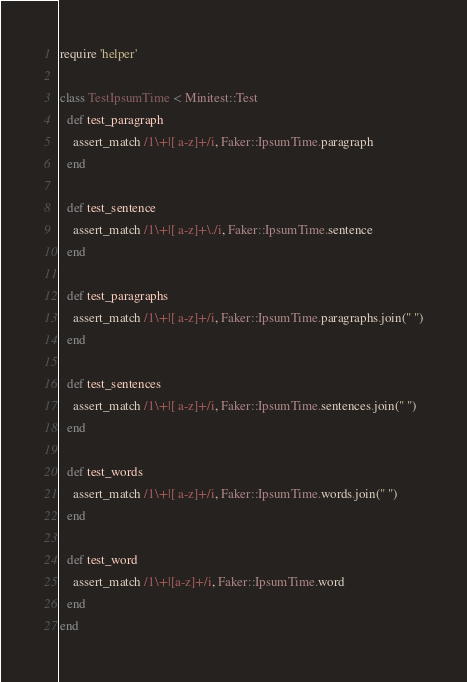Convert code to text. <code><loc_0><loc_0><loc_500><loc_500><_Ruby_>require 'helper'

class TestIpsumTime < Minitest::Test
  def test_paragraph
    assert_match /1\+|[ a-z]+/i, Faker::IpsumTime.paragraph
  end

  def test_sentence
    assert_match /1\+|[ a-z]+\./i, Faker::IpsumTime.sentence
  end

  def test_paragraphs
    assert_match /1\+|[ a-z]+/i, Faker::IpsumTime.paragraphs.join(" ")
  end

  def test_sentences
    assert_match /1\+|[ a-z]+/i, Faker::IpsumTime.sentences.join(" ")
  end

  def test_words
    assert_match /1\+|[ a-z]+/i, Faker::IpsumTime.words.join(" ")
  end

  def test_word
    assert_match /1\+|[a-z]+/i, Faker::IpsumTime.word
  end
end
</code> 